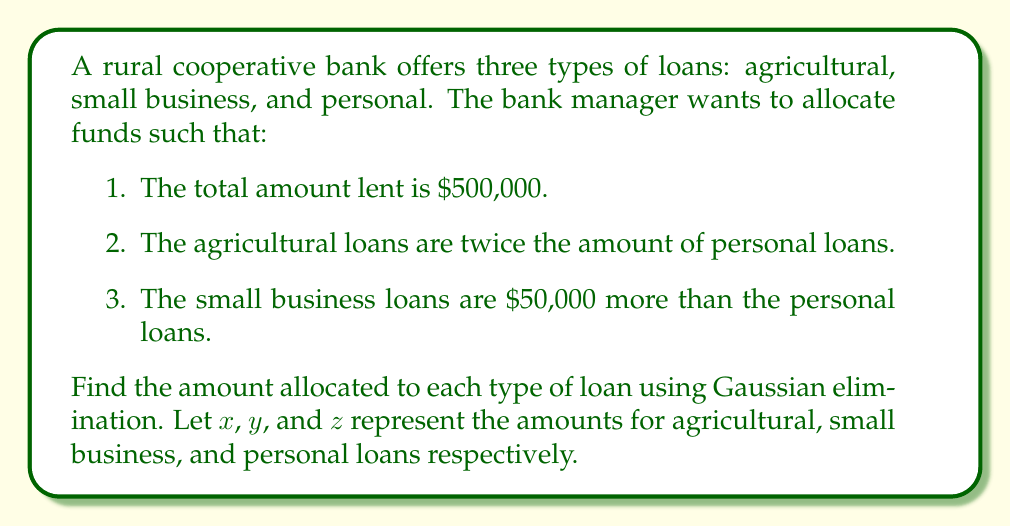Could you help me with this problem? Let's solve this problem using Gaussian elimination:

Step 1: Set up the system of linear equations
$$\begin{align}
x + y + z &= 500,000 \\
x - 2z &= 0 \\
y - z &= 50,000
\end{align}$$

Step 2: Write the augmented matrix
$$\begin{bmatrix}
1 & 1 & 1 & 500,000 \\
1 & 0 & -2 & 0 \\
0 & 1 & -1 & 50,000
\end{bmatrix}$$

Step 3: Use row operations to transform the matrix into row echelon form

a) Subtract row 2 from row 1
$$\begin{bmatrix}
0 & 1 & 3 & 500,000 \\
1 & 0 & -2 & 0 \\
0 & 1 & -1 & 50,000
\end{bmatrix}$$

b) Subtract row 3 from row 1
$$\begin{bmatrix}
0 & 0 & 4 & 450,000 \\
1 & 0 & -2 & 0 \\
0 & 1 & -1 & 50,000
\end{bmatrix}$$

Step 4: Back-substitution

a) From row 1: $4z = 450,000$, so $z = 112,500$

b) From row 3: $y - z = 50,000$
   $y - 112,500 = 50,000$
   $y = 162,500$

c) From row 2: $x - 2z = 0$
   $x - 2(112,500) = 0$
   $x = 225,000$

Step 5: Verify the solution
$$\begin{align}
225,000 + 162,500 + 112,500 &= 500,000 \\
225,000 - 2(112,500) &= 0 \\
162,500 - 112,500 &= 50,000
\end{align}$$

All equations are satisfied.
Answer: Agricultural loans: $225,000, Small business loans: $162,500, Personal loans: $112,500 